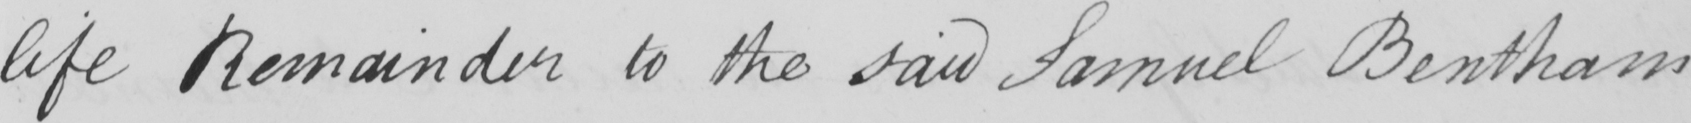What is written in this line of handwriting? life Remainder to the said Samuel Bentham 